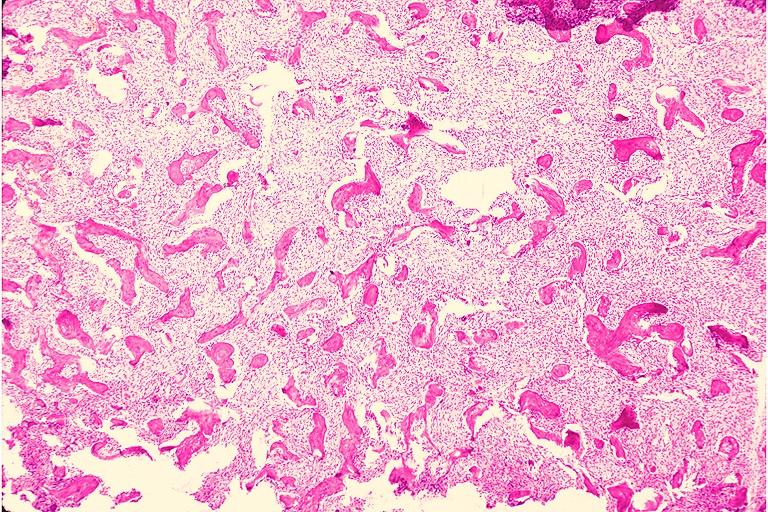s oral present?
Answer the question using a single word or phrase. Yes 